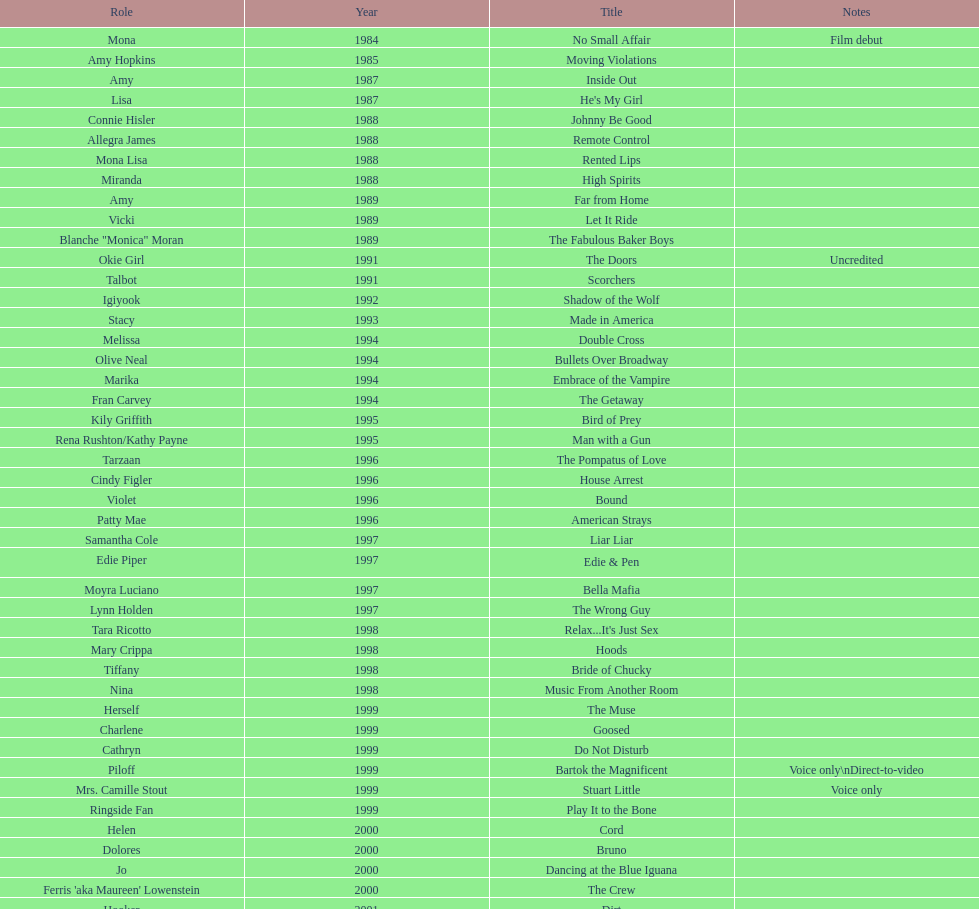Which year had the most credits? 2004. 